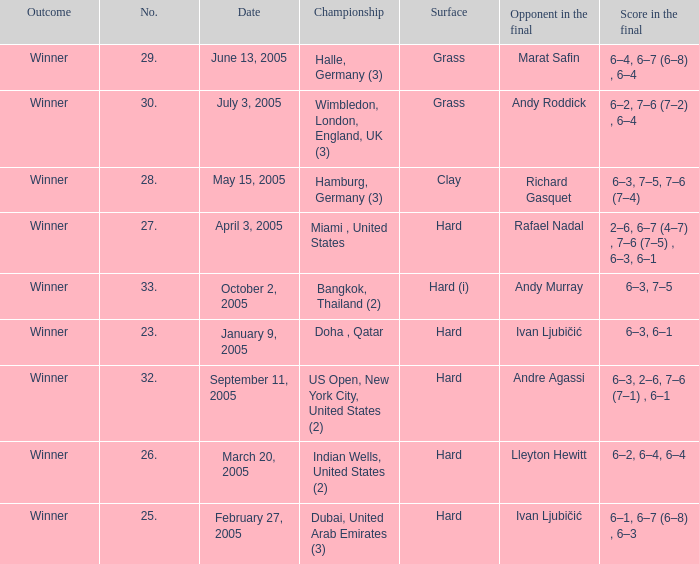Marat Safin is the opponent in the final in what championship? Halle, Germany (3). 